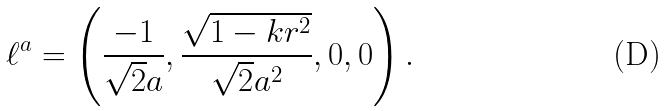<formula> <loc_0><loc_0><loc_500><loc_500>\ell ^ { a } = \left ( \frac { - 1 } { \sqrt { 2 } a } , \frac { \sqrt { 1 - k r ^ { 2 } } } { \sqrt { 2 } a ^ { 2 } } , 0 , 0 \right ) .</formula> 